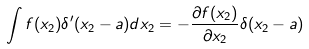Convert formula to latex. <formula><loc_0><loc_0><loc_500><loc_500>\int f ( x _ { 2 } ) \delta ^ { \prime } ( x _ { 2 } - a ) d x _ { 2 } = - \frac { \partial f ( x _ { 2 } ) } { \partial x _ { 2 } } \delta ( x _ { 2 } - a )</formula> 